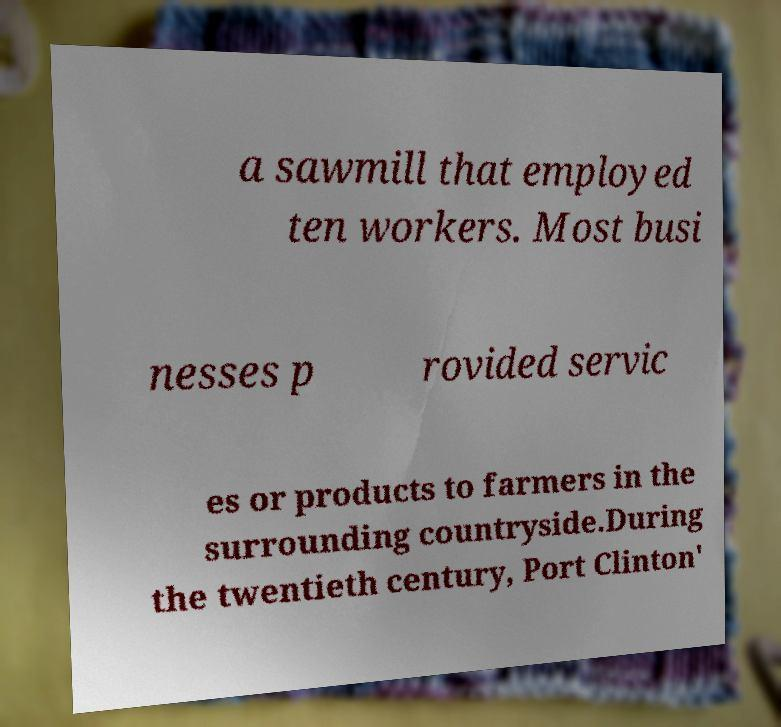Can you accurately transcribe the text from the provided image for me? a sawmill that employed ten workers. Most busi nesses p rovided servic es or products to farmers in the surrounding countryside.During the twentieth century, Port Clinton' 